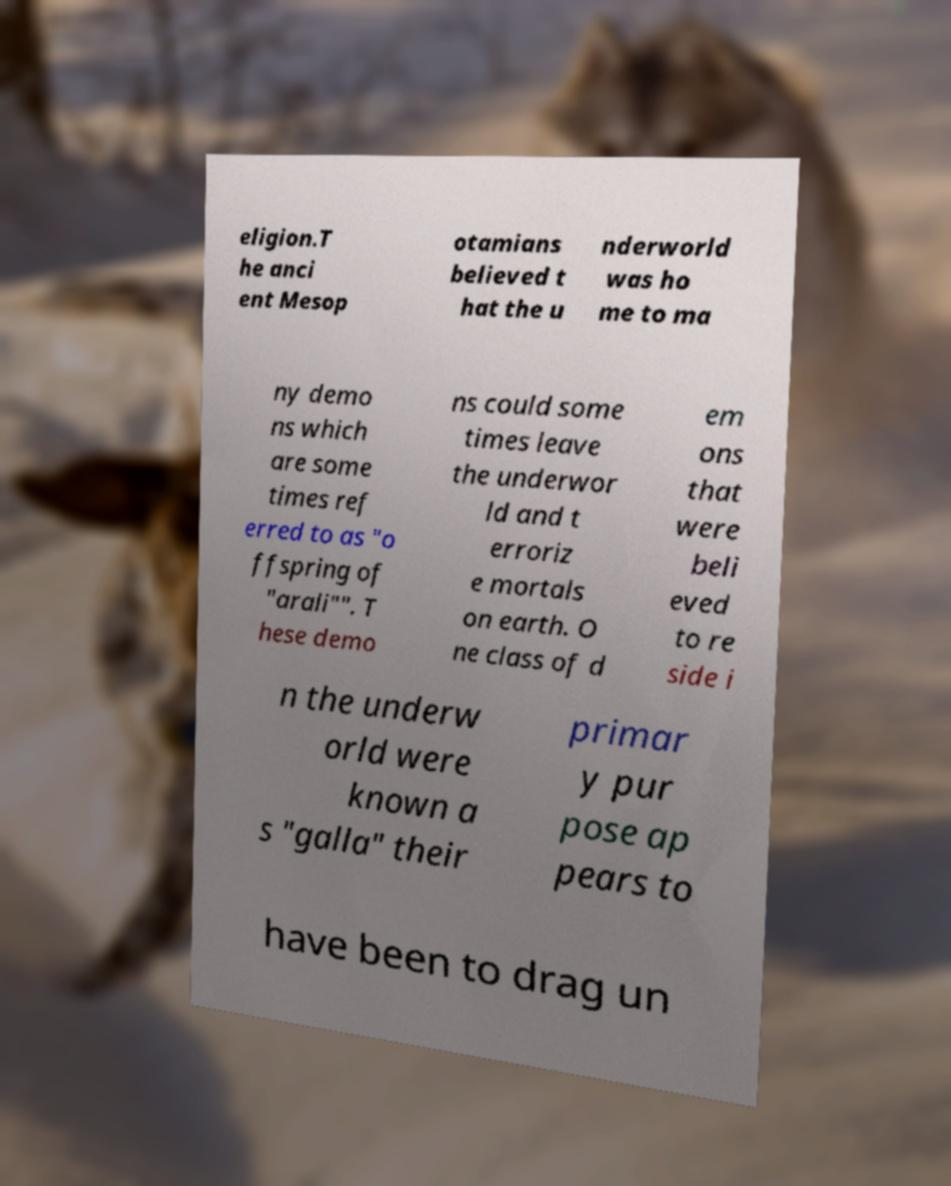Could you assist in decoding the text presented in this image and type it out clearly? eligion.T he anci ent Mesop otamians believed t hat the u nderworld was ho me to ma ny demo ns which are some times ref erred to as "o ffspring of "arali"". T hese demo ns could some times leave the underwor ld and t erroriz e mortals on earth. O ne class of d em ons that were beli eved to re side i n the underw orld were known a s "galla" their primar y pur pose ap pears to have been to drag un 